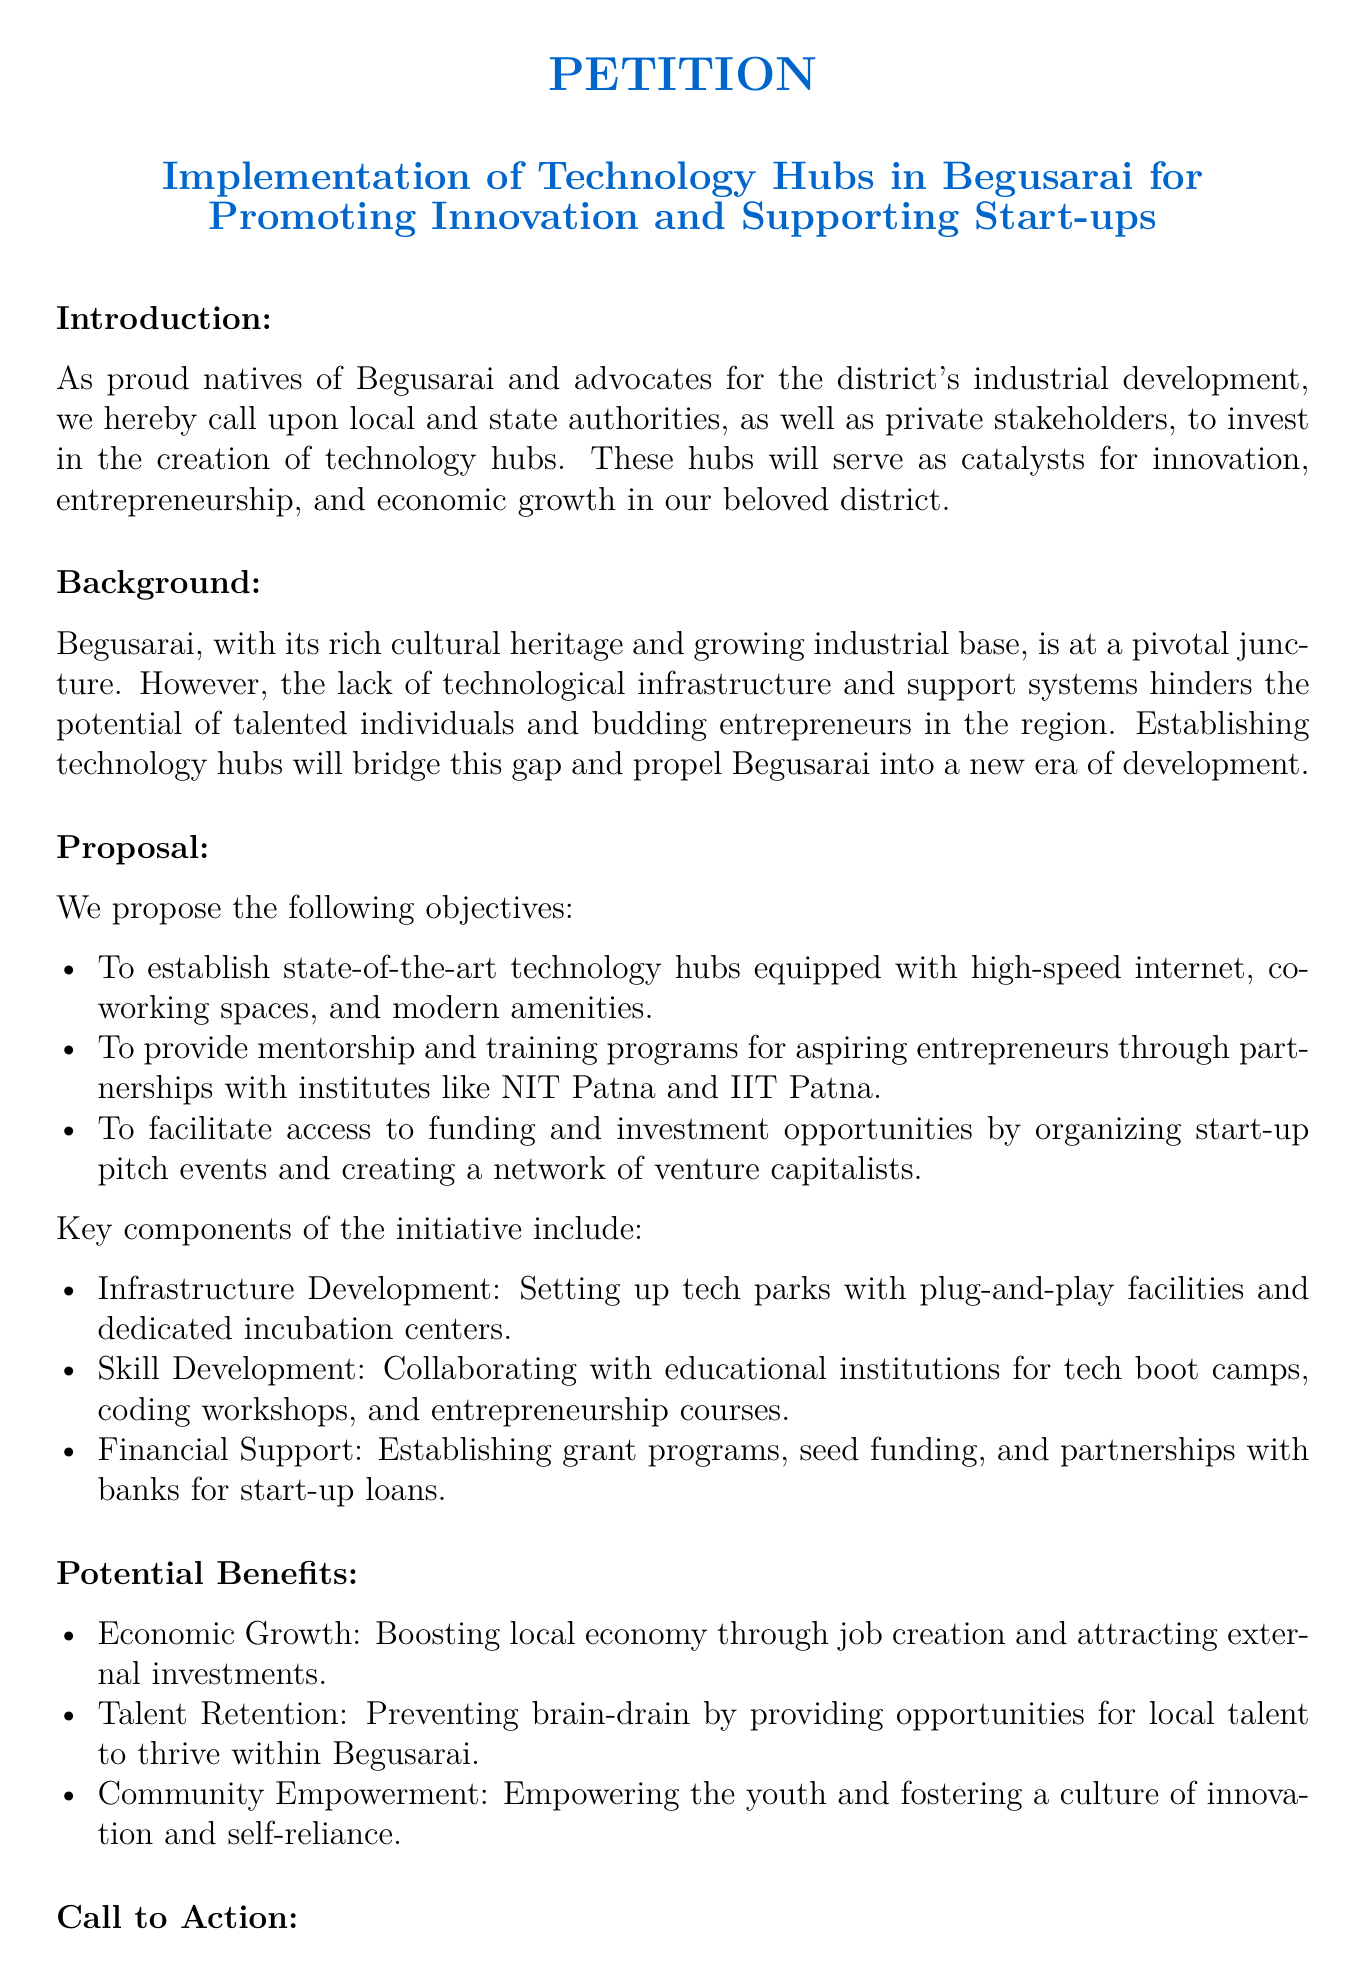What is the title of the petition? The title is clearly stated at the top of the document, which is focused on technology hubs and innovation in Begusarai.
Answer: Implementation of Technology Hubs in Begusarai for Promoting Innovation and Supporting Start-ups Who are the primary stakeholders mentioned in the petition? The petition calls upon local and state authorities, as well as private stakeholders, emphasizing their roles in this initiative.
Answer: local and state authorities, private stakeholders What is the proposed number of technology hubs? The document does not specify a number; it discusses hubs in plural, suggesting multiple hubs to be established.
Answer: multiple Which institutions are mentioned for partnership in mentorship programs? The two institutes referenced for collaboration in mentorship and training are significant sources of expertise for aspiring entrepreneurs.
Answer: NIT Patna and IIT Patna How many key components are listed in the initiative? The petition outlines several critical areas for the technology hub initiative, requiring a count of those components.
Answer: three What is one potential benefit of establishing technology hubs? The document lists various benefits, including economic growth, talent retention, and community empowerment.
Answer: Economic Growth What is required for the petition to be effective? The call to action section of the petition specifies the need for collaboration among various sectors for successful implementation.
Answer: collaboration When should individuals sign the petition? The document includes a space for signatures and dates, indicating that it is intended for immediate action and commitment to the cause.
Answer: immediately 